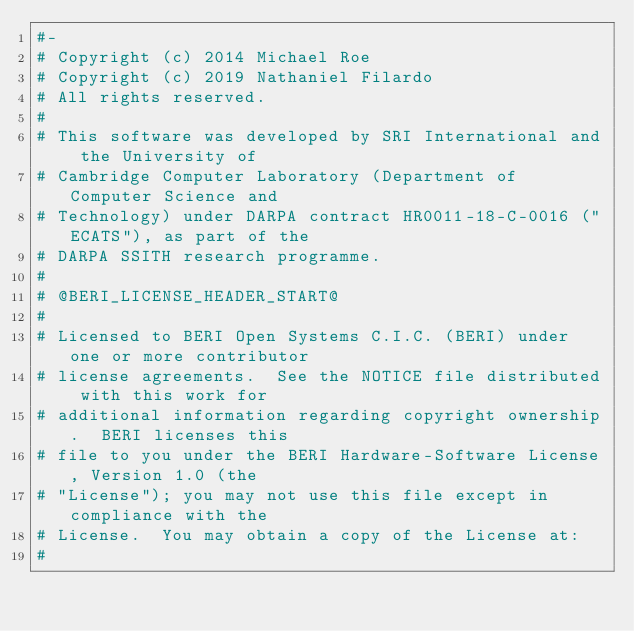<code> <loc_0><loc_0><loc_500><loc_500><_Python_>#-
# Copyright (c) 2014 Michael Roe
# Copyright (c) 2019 Nathaniel Filardo
# All rights reserved.
#
# This software was developed by SRI International and the University of
# Cambridge Computer Laboratory (Department of Computer Science and
# Technology) under DARPA contract HR0011-18-C-0016 ("ECATS"), as part of the
# DARPA SSITH research programme.
#
# @BERI_LICENSE_HEADER_START@
#
# Licensed to BERI Open Systems C.I.C. (BERI) under one or more contributor
# license agreements.  See the NOTICE file distributed with this work for
# additional information regarding copyright ownership.  BERI licenses this
# file to you under the BERI Hardware-Software License, Version 1.0 (the
# "License"); you may not use this file except in compliance with the
# License.  You may obtain a copy of the License at:
#</code> 